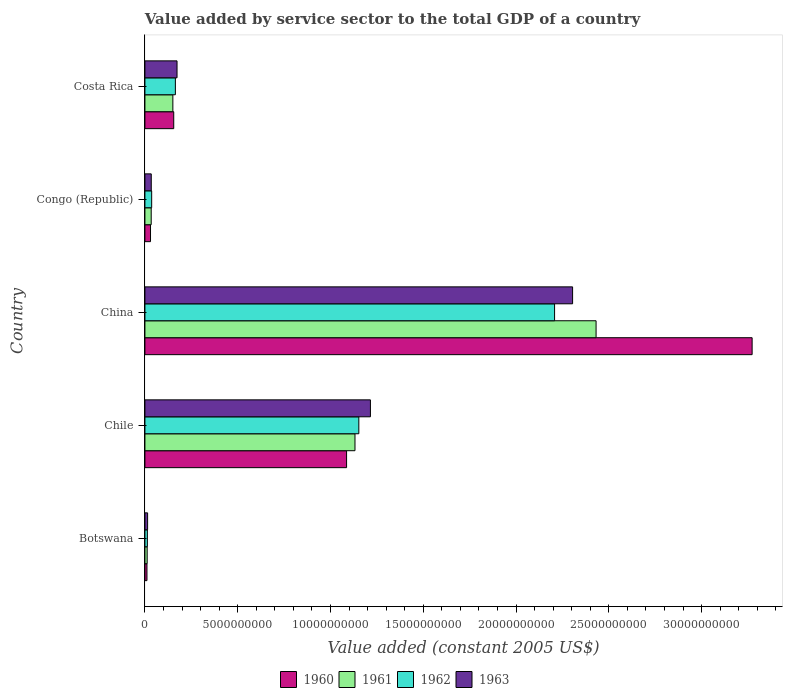Are the number of bars per tick equal to the number of legend labels?
Ensure brevity in your answer.  Yes. In how many cases, is the number of bars for a given country not equal to the number of legend labels?
Ensure brevity in your answer.  0. What is the value added by service sector in 1962 in Costa Rica?
Ensure brevity in your answer.  1.64e+09. Across all countries, what is the maximum value added by service sector in 1961?
Give a very brief answer. 2.43e+1. Across all countries, what is the minimum value added by service sector in 1961?
Your answer should be very brief. 1.22e+08. In which country was the value added by service sector in 1963 minimum?
Provide a succinct answer. Botswana. What is the total value added by service sector in 1960 in the graph?
Offer a terse response. 4.56e+1. What is the difference between the value added by service sector in 1963 in Botswana and that in Costa Rica?
Give a very brief answer. -1.59e+09. What is the difference between the value added by service sector in 1960 in Botswana and the value added by service sector in 1962 in Congo (Republic)?
Offer a terse response. -2.53e+08. What is the average value added by service sector in 1963 per country?
Make the answer very short. 7.48e+09. What is the difference between the value added by service sector in 1962 and value added by service sector in 1963 in China?
Give a very brief answer. -9.71e+08. In how many countries, is the value added by service sector in 1960 greater than 32000000000 US$?
Provide a succinct answer. 1. What is the ratio of the value added by service sector in 1963 in China to that in Congo (Republic)?
Your answer should be very brief. 67.39. Is the value added by service sector in 1961 in Chile less than that in China?
Provide a succinct answer. Yes. Is the difference between the value added by service sector in 1962 in Botswana and Chile greater than the difference between the value added by service sector in 1963 in Botswana and Chile?
Your answer should be very brief. Yes. What is the difference between the highest and the second highest value added by service sector in 1961?
Keep it short and to the point. 1.30e+1. What is the difference between the highest and the lowest value added by service sector in 1963?
Offer a very short reply. 2.29e+1. Is the sum of the value added by service sector in 1963 in Chile and Congo (Republic) greater than the maximum value added by service sector in 1962 across all countries?
Provide a short and direct response. No. Is it the case that in every country, the sum of the value added by service sector in 1961 and value added by service sector in 1960 is greater than the sum of value added by service sector in 1963 and value added by service sector in 1962?
Your answer should be compact. No. How many countries are there in the graph?
Your answer should be compact. 5. Are the values on the major ticks of X-axis written in scientific E-notation?
Provide a short and direct response. No. Does the graph contain any zero values?
Keep it short and to the point. No. What is the title of the graph?
Offer a very short reply. Value added by service sector to the total GDP of a country. What is the label or title of the X-axis?
Give a very brief answer. Value added (constant 2005 US$). What is the label or title of the Y-axis?
Your answer should be very brief. Country. What is the Value added (constant 2005 US$) in 1960 in Botswana?
Give a very brief answer. 1.11e+08. What is the Value added (constant 2005 US$) in 1961 in Botswana?
Offer a terse response. 1.22e+08. What is the Value added (constant 2005 US$) of 1962 in Botswana?
Make the answer very short. 1.32e+08. What is the Value added (constant 2005 US$) in 1963 in Botswana?
Offer a very short reply. 1.45e+08. What is the Value added (constant 2005 US$) of 1960 in Chile?
Provide a short and direct response. 1.09e+1. What is the Value added (constant 2005 US$) of 1961 in Chile?
Offer a very short reply. 1.13e+1. What is the Value added (constant 2005 US$) of 1962 in Chile?
Offer a very short reply. 1.15e+1. What is the Value added (constant 2005 US$) of 1963 in Chile?
Keep it short and to the point. 1.22e+1. What is the Value added (constant 2005 US$) in 1960 in China?
Provide a short and direct response. 3.27e+1. What is the Value added (constant 2005 US$) in 1961 in China?
Offer a terse response. 2.43e+1. What is the Value added (constant 2005 US$) of 1962 in China?
Offer a terse response. 2.21e+1. What is the Value added (constant 2005 US$) in 1963 in China?
Offer a terse response. 2.30e+1. What is the Value added (constant 2005 US$) in 1960 in Congo (Republic)?
Offer a terse response. 3.02e+08. What is the Value added (constant 2005 US$) in 1961 in Congo (Republic)?
Ensure brevity in your answer.  3.39e+08. What is the Value added (constant 2005 US$) of 1962 in Congo (Republic)?
Make the answer very short. 3.64e+08. What is the Value added (constant 2005 US$) of 1963 in Congo (Republic)?
Keep it short and to the point. 3.42e+08. What is the Value added (constant 2005 US$) of 1960 in Costa Rica?
Provide a succinct answer. 1.55e+09. What is the Value added (constant 2005 US$) of 1961 in Costa Rica?
Keep it short and to the point. 1.51e+09. What is the Value added (constant 2005 US$) in 1962 in Costa Rica?
Provide a succinct answer. 1.64e+09. What is the Value added (constant 2005 US$) of 1963 in Costa Rica?
Make the answer very short. 1.73e+09. Across all countries, what is the maximum Value added (constant 2005 US$) of 1960?
Ensure brevity in your answer.  3.27e+1. Across all countries, what is the maximum Value added (constant 2005 US$) of 1961?
Keep it short and to the point. 2.43e+1. Across all countries, what is the maximum Value added (constant 2005 US$) of 1962?
Offer a terse response. 2.21e+1. Across all countries, what is the maximum Value added (constant 2005 US$) of 1963?
Provide a short and direct response. 2.30e+1. Across all countries, what is the minimum Value added (constant 2005 US$) of 1960?
Offer a terse response. 1.11e+08. Across all countries, what is the minimum Value added (constant 2005 US$) in 1961?
Give a very brief answer. 1.22e+08. Across all countries, what is the minimum Value added (constant 2005 US$) in 1962?
Your answer should be compact. 1.32e+08. Across all countries, what is the minimum Value added (constant 2005 US$) in 1963?
Keep it short and to the point. 1.45e+08. What is the total Value added (constant 2005 US$) in 1960 in the graph?
Keep it short and to the point. 4.56e+1. What is the total Value added (constant 2005 US$) in 1961 in the graph?
Provide a succinct answer. 3.76e+1. What is the total Value added (constant 2005 US$) of 1962 in the graph?
Your answer should be very brief. 3.57e+1. What is the total Value added (constant 2005 US$) in 1963 in the graph?
Your answer should be compact. 3.74e+1. What is the difference between the Value added (constant 2005 US$) in 1960 in Botswana and that in Chile?
Offer a terse response. -1.08e+1. What is the difference between the Value added (constant 2005 US$) of 1961 in Botswana and that in Chile?
Your response must be concise. -1.12e+1. What is the difference between the Value added (constant 2005 US$) in 1962 in Botswana and that in Chile?
Offer a very short reply. -1.14e+1. What is the difference between the Value added (constant 2005 US$) in 1963 in Botswana and that in Chile?
Your answer should be compact. -1.20e+1. What is the difference between the Value added (constant 2005 US$) in 1960 in Botswana and that in China?
Make the answer very short. -3.26e+1. What is the difference between the Value added (constant 2005 US$) of 1961 in Botswana and that in China?
Make the answer very short. -2.42e+1. What is the difference between the Value added (constant 2005 US$) in 1962 in Botswana and that in China?
Offer a terse response. -2.19e+1. What is the difference between the Value added (constant 2005 US$) in 1963 in Botswana and that in China?
Keep it short and to the point. -2.29e+1. What is the difference between the Value added (constant 2005 US$) of 1960 in Botswana and that in Congo (Republic)?
Give a very brief answer. -1.91e+08. What is the difference between the Value added (constant 2005 US$) in 1961 in Botswana and that in Congo (Republic)?
Provide a short and direct response. -2.17e+08. What is the difference between the Value added (constant 2005 US$) in 1962 in Botswana and that in Congo (Republic)?
Your response must be concise. -2.32e+08. What is the difference between the Value added (constant 2005 US$) of 1963 in Botswana and that in Congo (Republic)?
Offer a terse response. -1.97e+08. What is the difference between the Value added (constant 2005 US$) of 1960 in Botswana and that in Costa Rica?
Provide a short and direct response. -1.44e+09. What is the difference between the Value added (constant 2005 US$) of 1961 in Botswana and that in Costa Rica?
Your response must be concise. -1.38e+09. What is the difference between the Value added (constant 2005 US$) of 1962 in Botswana and that in Costa Rica?
Provide a succinct answer. -1.51e+09. What is the difference between the Value added (constant 2005 US$) of 1963 in Botswana and that in Costa Rica?
Offer a very short reply. -1.59e+09. What is the difference between the Value added (constant 2005 US$) of 1960 in Chile and that in China?
Provide a succinct answer. -2.19e+1. What is the difference between the Value added (constant 2005 US$) of 1961 in Chile and that in China?
Give a very brief answer. -1.30e+1. What is the difference between the Value added (constant 2005 US$) of 1962 in Chile and that in China?
Ensure brevity in your answer.  -1.05e+1. What is the difference between the Value added (constant 2005 US$) of 1963 in Chile and that in China?
Make the answer very short. -1.09e+1. What is the difference between the Value added (constant 2005 US$) of 1960 in Chile and that in Congo (Republic)?
Provide a succinct answer. 1.06e+1. What is the difference between the Value added (constant 2005 US$) of 1961 in Chile and that in Congo (Republic)?
Make the answer very short. 1.10e+1. What is the difference between the Value added (constant 2005 US$) in 1962 in Chile and that in Congo (Republic)?
Keep it short and to the point. 1.12e+1. What is the difference between the Value added (constant 2005 US$) in 1963 in Chile and that in Congo (Republic)?
Provide a succinct answer. 1.18e+1. What is the difference between the Value added (constant 2005 US$) in 1960 in Chile and that in Costa Rica?
Provide a succinct answer. 9.31e+09. What is the difference between the Value added (constant 2005 US$) of 1961 in Chile and that in Costa Rica?
Provide a succinct answer. 9.81e+09. What is the difference between the Value added (constant 2005 US$) of 1962 in Chile and that in Costa Rica?
Keep it short and to the point. 9.89e+09. What is the difference between the Value added (constant 2005 US$) in 1963 in Chile and that in Costa Rica?
Offer a very short reply. 1.04e+1. What is the difference between the Value added (constant 2005 US$) in 1960 in China and that in Congo (Republic)?
Ensure brevity in your answer.  3.24e+1. What is the difference between the Value added (constant 2005 US$) of 1961 in China and that in Congo (Republic)?
Provide a short and direct response. 2.40e+1. What is the difference between the Value added (constant 2005 US$) of 1962 in China and that in Congo (Republic)?
Your response must be concise. 2.17e+1. What is the difference between the Value added (constant 2005 US$) in 1963 in China and that in Congo (Republic)?
Provide a short and direct response. 2.27e+1. What is the difference between the Value added (constant 2005 US$) of 1960 in China and that in Costa Rica?
Provide a succinct answer. 3.12e+1. What is the difference between the Value added (constant 2005 US$) of 1961 in China and that in Costa Rica?
Make the answer very short. 2.28e+1. What is the difference between the Value added (constant 2005 US$) in 1962 in China and that in Costa Rica?
Offer a very short reply. 2.04e+1. What is the difference between the Value added (constant 2005 US$) in 1963 in China and that in Costa Rica?
Provide a succinct answer. 2.13e+1. What is the difference between the Value added (constant 2005 US$) in 1960 in Congo (Republic) and that in Costa Rica?
Make the answer very short. -1.25e+09. What is the difference between the Value added (constant 2005 US$) in 1961 in Congo (Republic) and that in Costa Rica?
Provide a short and direct response. -1.17e+09. What is the difference between the Value added (constant 2005 US$) in 1962 in Congo (Republic) and that in Costa Rica?
Your answer should be very brief. -1.28e+09. What is the difference between the Value added (constant 2005 US$) in 1963 in Congo (Republic) and that in Costa Rica?
Your answer should be compact. -1.39e+09. What is the difference between the Value added (constant 2005 US$) in 1960 in Botswana and the Value added (constant 2005 US$) in 1961 in Chile?
Keep it short and to the point. -1.12e+1. What is the difference between the Value added (constant 2005 US$) in 1960 in Botswana and the Value added (constant 2005 US$) in 1962 in Chile?
Offer a very short reply. -1.14e+1. What is the difference between the Value added (constant 2005 US$) of 1960 in Botswana and the Value added (constant 2005 US$) of 1963 in Chile?
Offer a very short reply. -1.20e+1. What is the difference between the Value added (constant 2005 US$) in 1961 in Botswana and the Value added (constant 2005 US$) in 1962 in Chile?
Make the answer very short. -1.14e+1. What is the difference between the Value added (constant 2005 US$) of 1961 in Botswana and the Value added (constant 2005 US$) of 1963 in Chile?
Your answer should be compact. -1.20e+1. What is the difference between the Value added (constant 2005 US$) in 1962 in Botswana and the Value added (constant 2005 US$) in 1963 in Chile?
Provide a short and direct response. -1.20e+1. What is the difference between the Value added (constant 2005 US$) of 1960 in Botswana and the Value added (constant 2005 US$) of 1961 in China?
Provide a short and direct response. -2.42e+1. What is the difference between the Value added (constant 2005 US$) in 1960 in Botswana and the Value added (constant 2005 US$) in 1962 in China?
Ensure brevity in your answer.  -2.20e+1. What is the difference between the Value added (constant 2005 US$) in 1960 in Botswana and the Value added (constant 2005 US$) in 1963 in China?
Give a very brief answer. -2.29e+1. What is the difference between the Value added (constant 2005 US$) in 1961 in Botswana and the Value added (constant 2005 US$) in 1962 in China?
Your answer should be compact. -2.20e+1. What is the difference between the Value added (constant 2005 US$) of 1961 in Botswana and the Value added (constant 2005 US$) of 1963 in China?
Offer a terse response. -2.29e+1. What is the difference between the Value added (constant 2005 US$) of 1962 in Botswana and the Value added (constant 2005 US$) of 1963 in China?
Keep it short and to the point. -2.29e+1. What is the difference between the Value added (constant 2005 US$) of 1960 in Botswana and the Value added (constant 2005 US$) of 1961 in Congo (Republic)?
Make the answer very short. -2.28e+08. What is the difference between the Value added (constant 2005 US$) of 1960 in Botswana and the Value added (constant 2005 US$) of 1962 in Congo (Republic)?
Ensure brevity in your answer.  -2.53e+08. What is the difference between the Value added (constant 2005 US$) of 1960 in Botswana and the Value added (constant 2005 US$) of 1963 in Congo (Republic)?
Provide a succinct answer. -2.31e+08. What is the difference between the Value added (constant 2005 US$) in 1961 in Botswana and the Value added (constant 2005 US$) in 1962 in Congo (Republic)?
Provide a succinct answer. -2.42e+08. What is the difference between the Value added (constant 2005 US$) in 1961 in Botswana and the Value added (constant 2005 US$) in 1963 in Congo (Republic)?
Keep it short and to the point. -2.20e+08. What is the difference between the Value added (constant 2005 US$) in 1962 in Botswana and the Value added (constant 2005 US$) in 1963 in Congo (Republic)?
Your answer should be compact. -2.10e+08. What is the difference between the Value added (constant 2005 US$) in 1960 in Botswana and the Value added (constant 2005 US$) in 1961 in Costa Rica?
Your answer should be compact. -1.39e+09. What is the difference between the Value added (constant 2005 US$) of 1960 in Botswana and the Value added (constant 2005 US$) of 1962 in Costa Rica?
Provide a succinct answer. -1.53e+09. What is the difference between the Value added (constant 2005 US$) of 1960 in Botswana and the Value added (constant 2005 US$) of 1963 in Costa Rica?
Offer a terse response. -1.62e+09. What is the difference between the Value added (constant 2005 US$) of 1961 in Botswana and the Value added (constant 2005 US$) of 1962 in Costa Rica?
Ensure brevity in your answer.  -1.52e+09. What is the difference between the Value added (constant 2005 US$) of 1961 in Botswana and the Value added (constant 2005 US$) of 1963 in Costa Rica?
Give a very brief answer. -1.61e+09. What is the difference between the Value added (constant 2005 US$) in 1962 in Botswana and the Value added (constant 2005 US$) in 1963 in Costa Rica?
Offer a terse response. -1.60e+09. What is the difference between the Value added (constant 2005 US$) in 1960 in Chile and the Value added (constant 2005 US$) in 1961 in China?
Ensure brevity in your answer.  -1.34e+1. What is the difference between the Value added (constant 2005 US$) in 1960 in Chile and the Value added (constant 2005 US$) in 1962 in China?
Ensure brevity in your answer.  -1.12e+1. What is the difference between the Value added (constant 2005 US$) in 1960 in Chile and the Value added (constant 2005 US$) in 1963 in China?
Provide a succinct answer. -1.22e+1. What is the difference between the Value added (constant 2005 US$) in 1961 in Chile and the Value added (constant 2005 US$) in 1962 in China?
Keep it short and to the point. -1.08e+1. What is the difference between the Value added (constant 2005 US$) of 1961 in Chile and the Value added (constant 2005 US$) of 1963 in China?
Your answer should be very brief. -1.17e+1. What is the difference between the Value added (constant 2005 US$) of 1962 in Chile and the Value added (constant 2005 US$) of 1963 in China?
Keep it short and to the point. -1.15e+1. What is the difference between the Value added (constant 2005 US$) in 1960 in Chile and the Value added (constant 2005 US$) in 1961 in Congo (Republic)?
Your answer should be compact. 1.05e+1. What is the difference between the Value added (constant 2005 US$) in 1960 in Chile and the Value added (constant 2005 US$) in 1962 in Congo (Republic)?
Your answer should be very brief. 1.05e+1. What is the difference between the Value added (constant 2005 US$) of 1960 in Chile and the Value added (constant 2005 US$) of 1963 in Congo (Republic)?
Keep it short and to the point. 1.05e+1. What is the difference between the Value added (constant 2005 US$) of 1961 in Chile and the Value added (constant 2005 US$) of 1962 in Congo (Republic)?
Your response must be concise. 1.10e+1. What is the difference between the Value added (constant 2005 US$) of 1961 in Chile and the Value added (constant 2005 US$) of 1963 in Congo (Republic)?
Keep it short and to the point. 1.10e+1. What is the difference between the Value added (constant 2005 US$) of 1962 in Chile and the Value added (constant 2005 US$) of 1963 in Congo (Republic)?
Ensure brevity in your answer.  1.12e+1. What is the difference between the Value added (constant 2005 US$) of 1960 in Chile and the Value added (constant 2005 US$) of 1961 in Costa Rica?
Keep it short and to the point. 9.36e+09. What is the difference between the Value added (constant 2005 US$) of 1960 in Chile and the Value added (constant 2005 US$) of 1962 in Costa Rica?
Provide a succinct answer. 9.23e+09. What is the difference between the Value added (constant 2005 US$) in 1960 in Chile and the Value added (constant 2005 US$) in 1963 in Costa Rica?
Keep it short and to the point. 9.14e+09. What is the difference between the Value added (constant 2005 US$) of 1961 in Chile and the Value added (constant 2005 US$) of 1962 in Costa Rica?
Offer a very short reply. 9.68e+09. What is the difference between the Value added (constant 2005 US$) of 1961 in Chile and the Value added (constant 2005 US$) of 1963 in Costa Rica?
Provide a succinct answer. 9.59e+09. What is the difference between the Value added (constant 2005 US$) of 1962 in Chile and the Value added (constant 2005 US$) of 1963 in Costa Rica?
Ensure brevity in your answer.  9.80e+09. What is the difference between the Value added (constant 2005 US$) of 1960 in China and the Value added (constant 2005 US$) of 1961 in Congo (Republic)?
Your answer should be compact. 3.24e+1. What is the difference between the Value added (constant 2005 US$) of 1960 in China and the Value added (constant 2005 US$) of 1962 in Congo (Republic)?
Your answer should be very brief. 3.24e+1. What is the difference between the Value added (constant 2005 US$) of 1960 in China and the Value added (constant 2005 US$) of 1963 in Congo (Republic)?
Keep it short and to the point. 3.24e+1. What is the difference between the Value added (constant 2005 US$) of 1961 in China and the Value added (constant 2005 US$) of 1962 in Congo (Republic)?
Your response must be concise. 2.39e+1. What is the difference between the Value added (constant 2005 US$) of 1961 in China and the Value added (constant 2005 US$) of 1963 in Congo (Republic)?
Give a very brief answer. 2.40e+1. What is the difference between the Value added (constant 2005 US$) of 1962 in China and the Value added (constant 2005 US$) of 1963 in Congo (Republic)?
Provide a short and direct response. 2.17e+1. What is the difference between the Value added (constant 2005 US$) in 1960 in China and the Value added (constant 2005 US$) in 1961 in Costa Rica?
Provide a short and direct response. 3.12e+1. What is the difference between the Value added (constant 2005 US$) in 1960 in China and the Value added (constant 2005 US$) in 1962 in Costa Rica?
Your answer should be very brief. 3.11e+1. What is the difference between the Value added (constant 2005 US$) in 1960 in China and the Value added (constant 2005 US$) in 1963 in Costa Rica?
Your response must be concise. 3.10e+1. What is the difference between the Value added (constant 2005 US$) of 1961 in China and the Value added (constant 2005 US$) of 1962 in Costa Rica?
Provide a succinct answer. 2.27e+1. What is the difference between the Value added (constant 2005 US$) of 1961 in China and the Value added (constant 2005 US$) of 1963 in Costa Rica?
Your response must be concise. 2.26e+1. What is the difference between the Value added (constant 2005 US$) of 1962 in China and the Value added (constant 2005 US$) of 1963 in Costa Rica?
Offer a very short reply. 2.03e+1. What is the difference between the Value added (constant 2005 US$) of 1960 in Congo (Republic) and the Value added (constant 2005 US$) of 1961 in Costa Rica?
Provide a succinct answer. -1.20e+09. What is the difference between the Value added (constant 2005 US$) in 1960 in Congo (Republic) and the Value added (constant 2005 US$) in 1962 in Costa Rica?
Provide a short and direct response. -1.34e+09. What is the difference between the Value added (constant 2005 US$) of 1960 in Congo (Republic) and the Value added (constant 2005 US$) of 1963 in Costa Rica?
Your answer should be compact. -1.43e+09. What is the difference between the Value added (constant 2005 US$) of 1961 in Congo (Republic) and the Value added (constant 2005 US$) of 1962 in Costa Rica?
Ensure brevity in your answer.  -1.30e+09. What is the difference between the Value added (constant 2005 US$) in 1961 in Congo (Republic) and the Value added (constant 2005 US$) in 1963 in Costa Rica?
Your response must be concise. -1.39e+09. What is the difference between the Value added (constant 2005 US$) of 1962 in Congo (Republic) and the Value added (constant 2005 US$) of 1963 in Costa Rica?
Provide a succinct answer. -1.37e+09. What is the average Value added (constant 2005 US$) in 1960 per country?
Keep it short and to the point. 9.11e+09. What is the average Value added (constant 2005 US$) in 1961 per country?
Keep it short and to the point. 7.52e+09. What is the average Value added (constant 2005 US$) in 1962 per country?
Offer a very short reply. 7.15e+09. What is the average Value added (constant 2005 US$) in 1963 per country?
Your answer should be very brief. 7.48e+09. What is the difference between the Value added (constant 2005 US$) in 1960 and Value added (constant 2005 US$) in 1961 in Botswana?
Ensure brevity in your answer.  -1.12e+07. What is the difference between the Value added (constant 2005 US$) of 1960 and Value added (constant 2005 US$) of 1962 in Botswana?
Offer a very short reply. -2.17e+07. What is the difference between the Value added (constant 2005 US$) of 1960 and Value added (constant 2005 US$) of 1963 in Botswana?
Give a very brief answer. -3.45e+07. What is the difference between the Value added (constant 2005 US$) in 1961 and Value added (constant 2005 US$) in 1962 in Botswana?
Your response must be concise. -1.05e+07. What is the difference between the Value added (constant 2005 US$) of 1961 and Value added (constant 2005 US$) of 1963 in Botswana?
Ensure brevity in your answer.  -2.33e+07. What is the difference between the Value added (constant 2005 US$) in 1962 and Value added (constant 2005 US$) in 1963 in Botswana?
Ensure brevity in your answer.  -1.28e+07. What is the difference between the Value added (constant 2005 US$) in 1960 and Value added (constant 2005 US$) in 1961 in Chile?
Provide a short and direct response. -4.53e+08. What is the difference between the Value added (constant 2005 US$) of 1960 and Value added (constant 2005 US$) of 1962 in Chile?
Your response must be concise. -6.60e+08. What is the difference between the Value added (constant 2005 US$) of 1960 and Value added (constant 2005 US$) of 1963 in Chile?
Offer a terse response. -1.29e+09. What is the difference between the Value added (constant 2005 US$) of 1961 and Value added (constant 2005 US$) of 1962 in Chile?
Keep it short and to the point. -2.07e+08. What is the difference between the Value added (constant 2005 US$) in 1961 and Value added (constant 2005 US$) in 1963 in Chile?
Your answer should be very brief. -8.32e+08. What is the difference between the Value added (constant 2005 US$) of 1962 and Value added (constant 2005 US$) of 1963 in Chile?
Your response must be concise. -6.25e+08. What is the difference between the Value added (constant 2005 US$) in 1960 and Value added (constant 2005 US$) in 1961 in China?
Keep it short and to the point. 8.41e+09. What is the difference between the Value added (constant 2005 US$) of 1960 and Value added (constant 2005 US$) of 1962 in China?
Offer a terse response. 1.06e+1. What is the difference between the Value added (constant 2005 US$) of 1960 and Value added (constant 2005 US$) of 1963 in China?
Offer a terse response. 9.68e+09. What is the difference between the Value added (constant 2005 US$) of 1961 and Value added (constant 2005 US$) of 1962 in China?
Provide a succinct answer. 2.24e+09. What is the difference between the Value added (constant 2005 US$) of 1961 and Value added (constant 2005 US$) of 1963 in China?
Your response must be concise. 1.27e+09. What is the difference between the Value added (constant 2005 US$) of 1962 and Value added (constant 2005 US$) of 1963 in China?
Ensure brevity in your answer.  -9.71e+08. What is the difference between the Value added (constant 2005 US$) of 1960 and Value added (constant 2005 US$) of 1961 in Congo (Republic)?
Your answer should be compact. -3.74e+07. What is the difference between the Value added (constant 2005 US$) in 1960 and Value added (constant 2005 US$) in 1962 in Congo (Republic)?
Offer a terse response. -6.23e+07. What is the difference between the Value added (constant 2005 US$) of 1960 and Value added (constant 2005 US$) of 1963 in Congo (Republic)?
Ensure brevity in your answer.  -4.05e+07. What is the difference between the Value added (constant 2005 US$) of 1961 and Value added (constant 2005 US$) of 1962 in Congo (Republic)?
Provide a succinct answer. -2.49e+07. What is the difference between the Value added (constant 2005 US$) in 1961 and Value added (constant 2005 US$) in 1963 in Congo (Republic)?
Offer a very short reply. -3.09e+06. What is the difference between the Value added (constant 2005 US$) in 1962 and Value added (constant 2005 US$) in 1963 in Congo (Republic)?
Your answer should be very brief. 2.18e+07. What is the difference between the Value added (constant 2005 US$) of 1960 and Value added (constant 2005 US$) of 1961 in Costa Rica?
Offer a terse response. 4.72e+07. What is the difference between the Value added (constant 2005 US$) in 1960 and Value added (constant 2005 US$) in 1962 in Costa Rica?
Make the answer very short. -8.87e+07. What is the difference between the Value added (constant 2005 US$) of 1960 and Value added (constant 2005 US$) of 1963 in Costa Rica?
Keep it short and to the point. -1.78e+08. What is the difference between the Value added (constant 2005 US$) of 1961 and Value added (constant 2005 US$) of 1962 in Costa Rica?
Provide a short and direct response. -1.36e+08. What is the difference between the Value added (constant 2005 US$) in 1961 and Value added (constant 2005 US$) in 1963 in Costa Rica?
Your response must be concise. -2.25e+08. What is the difference between the Value added (constant 2005 US$) in 1962 and Value added (constant 2005 US$) in 1963 in Costa Rica?
Keep it short and to the point. -8.94e+07. What is the ratio of the Value added (constant 2005 US$) of 1960 in Botswana to that in Chile?
Provide a succinct answer. 0.01. What is the ratio of the Value added (constant 2005 US$) in 1961 in Botswana to that in Chile?
Ensure brevity in your answer.  0.01. What is the ratio of the Value added (constant 2005 US$) of 1962 in Botswana to that in Chile?
Provide a succinct answer. 0.01. What is the ratio of the Value added (constant 2005 US$) of 1963 in Botswana to that in Chile?
Provide a succinct answer. 0.01. What is the ratio of the Value added (constant 2005 US$) in 1960 in Botswana to that in China?
Offer a very short reply. 0. What is the ratio of the Value added (constant 2005 US$) of 1961 in Botswana to that in China?
Your response must be concise. 0.01. What is the ratio of the Value added (constant 2005 US$) of 1962 in Botswana to that in China?
Offer a very short reply. 0.01. What is the ratio of the Value added (constant 2005 US$) of 1963 in Botswana to that in China?
Your answer should be very brief. 0.01. What is the ratio of the Value added (constant 2005 US$) in 1960 in Botswana to that in Congo (Republic)?
Offer a terse response. 0.37. What is the ratio of the Value added (constant 2005 US$) in 1961 in Botswana to that in Congo (Republic)?
Your response must be concise. 0.36. What is the ratio of the Value added (constant 2005 US$) in 1962 in Botswana to that in Congo (Republic)?
Your response must be concise. 0.36. What is the ratio of the Value added (constant 2005 US$) of 1963 in Botswana to that in Congo (Republic)?
Your answer should be very brief. 0.42. What is the ratio of the Value added (constant 2005 US$) of 1960 in Botswana to that in Costa Rica?
Offer a terse response. 0.07. What is the ratio of the Value added (constant 2005 US$) in 1961 in Botswana to that in Costa Rica?
Provide a short and direct response. 0.08. What is the ratio of the Value added (constant 2005 US$) of 1962 in Botswana to that in Costa Rica?
Provide a short and direct response. 0.08. What is the ratio of the Value added (constant 2005 US$) in 1963 in Botswana to that in Costa Rica?
Your answer should be very brief. 0.08. What is the ratio of the Value added (constant 2005 US$) of 1960 in Chile to that in China?
Make the answer very short. 0.33. What is the ratio of the Value added (constant 2005 US$) in 1961 in Chile to that in China?
Offer a very short reply. 0.47. What is the ratio of the Value added (constant 2005 US$) in 1962 in Chile to that in China?
Give a very brief answer. 0.52. What is the ratio of the Value added (constant 2005 US$) in 1963 in Chile to that in China?
Provide a short and direct response. 0.53. What is the ratio of the Value added (constant 2005 US$) of 1960 in Chile to that in Congo (Republic)?
Offer a very short reply. 36.04. What is the ratio of the Value added (constant 2005 US$) of 1961 in Chile to that in Congo (Republic)?
Give a very brief answer. 33.4. What is the ratio of the Value added (constant 2005 US$) of 1962 in Chile to that in Congo (Republic)?
Offer a very short reply. 31.68. What is the ratio of the Value added (constant 2005 US$) of 1963 in Chile to that in Congo (Republic)?
Make the answer very short. 35.53. What is the ratio of the Value added (constant 2005 US$) of 1960 in Chile to that in Costa Rica?
Offer a very short reply. 7. What is the ratio of the Value added (constant 2005 US$) of 1961 in Chile to that in Costa Rica?
Make the answer very short. 7.52. What is the ratio of the Value added (constant 2005 US$) in 1962 in Chile to that in Costa Rica?
Give a very brief answer. 7.02. What is the ratio of the Value added (constant 2005 US$) in 1963 in Chile to that in Costa Rica?
Offer a terse response. 7.02. What is the ratio of the Value added (constant 2005 US$) in 1960 in China to that in Congo (Republic)?
Provide a succinct answer. 108.51. What is the ratio of the Value added (constant 2005 US$) of 1961 in China to that in Congo (Republic)?
Keep it short and to the point. 71.73. What is the ratio of the Value added (constant 2005 US$) of 1962 in China to that in Congo (Republic)?
Provide a succinct answer. 60.67. What is the ratio of the Value added (constant 2005 US$) of 1963 in China to that in Congo (Republic)?
Offer a terse response. 67.39. What is the ratio of the Value added (constant 2005 US$) in 1960 in China to that in Costa Rica?
Provide a short and direct response. 21.08. What is the ratio of the Value added (constant 2005 US$) of 1961 in China to that in Costa Rica?
Give a very brief answer. 16.15. What is the ratio of the Value added (constant 2005 US$) in 1962 in China to that in Costa Rica?
Provide a succinct answer. 13.45. What is the ratio of the Value added (constant 2005 US$) in 1963 in China to that in Costa Rica?
Your answer should be compact. 13.32. What is the ratio of the Value added (constant 2005 US$) in 1960 in Congo (Republic) to that in Costa Rica?
Provide a succinct answer. 0.19. What is the ratio of the Value added (constant 2005 US$) of 1961 in Congo (Republic) to that in Costa Rica?
Keep it short and to the point. 0.23. What is the ratio of the Value added (constant 2005 US$) of 1962 in Congo (Republic) to that in Costa Rica?
Provide a succinct answer. 0.22. What is the ratio of the Value added (constant 2005 US$) in 1963 in Congo (Republic) to that in Costa Rica?
Give a very brief answer. 0.2. What is the difference between the highest and the second highest Value added (constant 2005 US$) of 1960?
Your response must be concise. 2.19e+1. What is the difference between the highest and the second highest Value added (constant 2005 US$) of 1961?
Your answer should be very brief. 1.30e+1. What is the difference between the highest and the second highest Value added (constant 2005 US$) of 1962?
Give a very brief answer. 1.05e+1. What is the difference between the highest and the second highest Value added (constant 2005 US$) of 1963?
Offer a very short reply. 1.09e+1. What is the difference between the highest and the lowest Value added (constant 2005 US$) in 1960?
Your response must be concise. 3.26e+1. What is the difference between the highest and the lowest Value added (constant 2005 US$) of 1961?
Provide a succinct answer. 2.42e+1. What is the difference between the highest and the lowest Value added (constant 2005 US$) of 1962?
Your answer should be very brief. 2.19e+1. What is the difference between the highest and the lowest Value added (constant 2005 US$) of 1963?
Your response must be concise. 2.29e+1. 